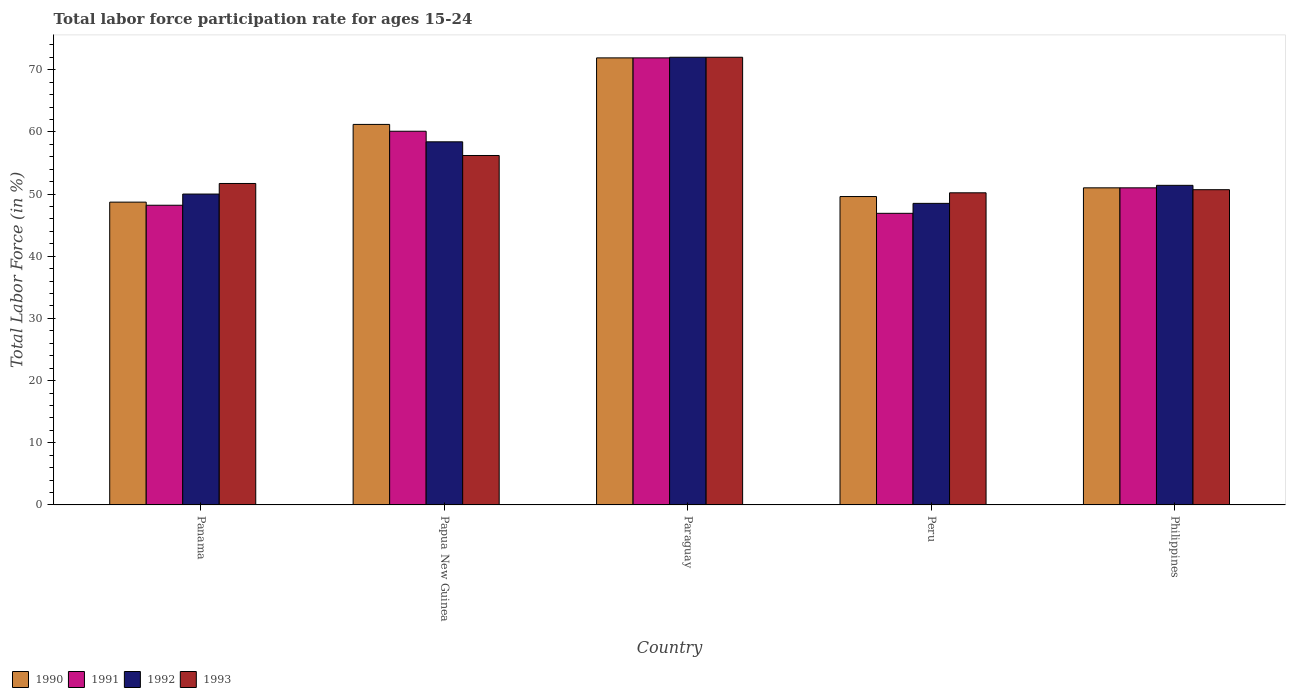How many groups of bars are there?
Your answer should be very brief. 5. Are the number of bars per tick equal to the number of legend labels?
Your answer should be compact. Yes. Are the number of bars on each tick of the X-axis equal?
Ensure brevity in your answer.  Yes. How many bars are there on the 4th tick from the left?
Keep it short and to the point. 4. How many bars are there on the 2nd tick from the right?
Your response must be concise. 4. What is the label of the 1st group of bars from the left?
Offer a very short reply. Panama. In how many cases, is the number of bars for a given country not equal to the number of legend labels?
Ensure brevity in your answer.  0. Across all countries, what is the maximum labor force participation rate in 1990?
Ensure brevity in your answer.  71.9. Across all countries, what is the minimum labor force participation rate in 1993?
Provide a succinct answer. 50.2. In which country was the labor force participation rate in 1993 maximum?
Provide a short and direct response. Paraguay. In which country was the labor force participation rate in 1990 minimum?
Your answer should be very brief. Panama. What is the total labor force participation rate in 1991 in the graph?
Provide a short and direct response. 278.1. What is the difference between the labor force participation rate in 1993 in Panama and that in Paraguay?
Make the answer very short. -20.3. What is the difference between the labor force participation rate in 1991 in Papua New Guinea and the labor force participation rate in 1993 in Paraguay?
Provide a succinct answer. -11.9. What is the average labor force participation rate in 1991 per country?
Ensure brevity in your answer.  55.62. What is the difference between the labor force participation rate of/in 1993 and labor force participation rate of/in 1992 in Panama?
Give a very brief answer. 1.7. What is the ratio of the labor force participation rate in 1990 in Panama to that in Philippines?
Provide a short and direct response. 0.95. Is the labor force participation rate in 1993 in Papua New Guinea less than that in Paraguay?
Offer a very short reply. Yes. What is the difference between the highest and the second highest labor force participation rate in 1991?
Your answer should be very brief. -9.1. What is the difference between the highest and the lowest labor force participation rate in 1991?
Provide a short and direct response. 25. Is the sum of the labor force participation rate in 1992 in Panama and Paraguay greater than the maximum labor force participation rate in 1993 across all countries?
Give a very brief answer. Yes. Is it the case that in every country, the sum of the labor force participation rate in 1990 and labor force participation rate in 1992 is greater than the sum of labor force participation rate in 1991 and labor force participation rate in 1993?
Provide a succinct answer. No. What does the 3rd bar from the left in Panama represents?
Make the answer very short. 1992. Is it the case that in every country, the sum of the labor force participation rate in 1990 and labor force participation rate in 1992 is greater than the labor force participation rate in 1993?
Your answer should be compact. Yes. How many bars are there?
Give a very brief answer. 20. Are all the bars in the graph horizontal?
Your answer should be compact. No. What is the difference between two consecutive major ticks on the Y-axis?
Make the answer very short. 10. Are the values on the major ticks of Y-axis written in scientific E-notation?
Offer a very short reply. No. Does the graph contain any zero values?
Your answer should be very brief. No. Does the graph contain grids?
Ensure brevity in your answer.  No. How are the legend labels stacked?
Provide a succinct answer. Horizontal. What is the title of the graph?
Provide a succinct answer. Total labor force participation rate for ages 15-24. What is the Total Labor Force (in %) in 1990 in Panama?
Make the answer very short. 48.7. What is the Total Labor Force (in %) in 1991 in Panama?
Your answer should be very brief. 48.2. What is the Total Labor Force (in %) in 1993 in Panama?
Your answer should be compact. 51.7. What is the Total Labor Force (in %) in 1990 in Papua New Guinea?
Your answer should be compact. 61.2. What is the Total Labor Force (in %) in 1991 in Papua New Guinea?
Your response must be concise. 60.1. What is the Total Labor Force (in %) of 1992 in Papua New Guinea?
Provide a short and direct response. 58.4. What is the Total Labor Force (in %) in 1993 in Papua New Guinea?
Offer a terse response. 56.2. What is the Total Labor Force (in %) of 1990 in Paraguay?
Keep it short and to the point. 71.9. What is the Total Labor Force (in %) of 1991 in Paraguay?
Provide a short and direct response. 71.9. What is the Total Labor Force (in %) of 1990 in Peru?
Offer a terse response. 49.6. What is the Total Labor Force (in %) in 1991 in Peru?
Provide a succinct answer. 46.9. What is the Total Labor Force (in %) of 1992 in Peru?
Ensure brevity in your answer.  48.5. What is the Total Labor Force (in %) of 1993 in Peru?
Keep it short and to the point. 50.2. What is the Total Labor Force (in %) of 1992 in Philippines?
Keep it short and to the point. 51.4. What is the Total Labor Force (in %) in 1993 in Philippines?
Your answer should be compact. 50.7. Across all countries, what is the maximum Total Labor Force (in %) in 1990?
Ensure brevity in your answer.  71.9. Across all countries, what is the maximum Total Labor Force (in %) in 1991?
Provide a short and direct response. 71.9. Across all countries, what is the maximum Total Labor Force (in %) in 1992?
Provide a short and direct response. 72. Across all countries, what is the maximum Total Labor Force (in %) of 1993?
Your answer should be very brief. 72. Across all countries, what is the minimum Total Labor Force (in %) in 1990?
Provide a succinct answer. 48.7. Across all countries, what is the minimum Total Labor Force (in %) in 1991?
Your answer should be very brief. 46.9. Across all countries, what is the minimum Total Labor Force (in %) of 1992?
Your answer should be very brief. 48.5. Across all countries, what is the minimum Total Labor Force (in %) in 1993?
Your response must be concise. 50.2. What is the total Total Labor Force (in %) of 1990 in the graph?
Ensure brevity in your answer.  282.4. What is the total Total Labor Force (in %) in 1991 in the graph?
Make the answer very short. 278.1. What is the total Total Labor Force (in %) in 1992 in the graph?
Provide a short and direct response. 280.3. What is the total Total Labor Force (in %) of 1993 in the graph?
Ensure brevity in your answer.  280.8. What is the difference between the Total Labor Force (in %) in 1990 in Panama and that in Papua New Guinea?
Your answer should be very brief. -12.5. What is the difference between the Total Labor Force (in %) in 1991 in Panama and that in Papua New Guinea?
Provide a succinct answer. -11.9. What is the difference between the Total Labor Force (in %) in 1990 in Panama and that in Paraguay?
Your answer should be very brief. -23.2. What is the difference between the Total Labor Force (in %) of 1991 in Panama and that in Paraguay?
Offer a very short reply. -23.7. What is the difference between the Total Labor Force (in %) in 1992 in Panama and that in Paraguay?
Your answer should be very brief. -22. What is the difference between the Total Labor Force (in %) of 1993 in Panama and that in Paraguay?
Your answer should be compact. -20.3. What is the difference between the Total Labor Force (in %) of 1990 in Panama and that in Peru?
Offer a very short reply. -0.9. What is the difference between the Total Labor Force (in %) of 1992 in Panama and that in Peru?
Keep it short and to the point. 1.5. What is the difference between the Total Labor Force (in %) in 1990 in Panama and that in Philippines?
Your answer should be very brief. -2.3. What is the difference between the Total Labor Force (in %) in 1992 in Panama and that in Philippines?
Give a very brief answer. -1.4. What is the difference between the Total Labor Force (in %) in 1992 in Papua New Guinea and that in Paraguay?
Your answer should be compact. -13.6. What is the difference between the Total Labor Force (in %) in 1993 in Papua New Guinea and that in Paraguay?
Ensure brevity in your answer.  -15.8. What is the difference between the Total Labor Force (in %) of 1990 in Papua New Guinea and that in Peru?
Your answer should be very brief. 11.6. What is the difference between the Total Labor Force (in %) in 1991 in Papua New Guinea and that in Peru?
Your answer should be compact. 13.2. What is the difference between the Total Labor Force (in %) of 1993 in Papua New Guinea and that in Peru?
Provide a short and direct response. 6. What is the difference between the Total Labor Force (in %) in 1991 in Papua New Guinea and that in Philippines?
Give a very brief answer. 9.1. What is the difference between the Total Labor Force (in %) of 1993 in Papua New Guinea and that in Philippines?
Keep it short and to the point. 5.5. What is the difference between the Total Labor Force (in %) of 1990 in Paraguay and that in Peru?
Offer a terse response. 22.3. What is the difference between the Total Labor Force (in %) in 1992 in Paraguay and that in Peru?
Your response must be concise. 23.5. What is the difference between the Total Labor Force (in %) of 1993 in Paraguay and that in Peru?
Your answer should be compact. 21.8. What is the difference between the Total Labor Force (in %) of 1990 in Paraguay and that in Philippines?
Your response must be concise. 20.9. What is the difference between the Total Labor Force (in %) in 1991 in Paraguay and that in Philippines?
Give a very brief answer. 20.9. What is the difference between the Total Labor Force (in %) in 1992 in Paraguay and that in Philippines?
Ensure brevity in your answer.  20.6. What is the difference between the Total Labor Force (in %) in 1993 in Paraguay and that in Philippines?
Your answer should be compact. 21.3. What is the difference between the Total Labor Force (in %) of 1992 in Peru and that in Philippines?
Your response must be concise. -2.9. What is the difference between the Total Labor Force (in %) in 1993 in Peru and that in Philippines?
Keep it short and to the point. -0.5. What is the difference between the Total Labor Force (in %) in 1990 in Panama and the Total Labor Force (in %) in 1991 in Papua New Guinea?
Make the answer very short. -11.4. What is the difference between the Total Labor Force (in %) of 1991 in Panama and the Total Labor Force (in %) of 1992 in Papua New Guinea?
Your answer should be very brief. -10.2. What is the difference between the Total Labor Force (in %) of 1991 in Panama and the Total Labor Force (in %) of 1993 in Papua New Guinea?
Ensure brevity in your answer.  -8. What is the difference between the Total Labor Force (in %) in 1992 in Panama and the Total Labor Force (in %) in 1993 in Papua New Guinea?
Offer a very short reply. -6.2. What is the difference between the Total Labor Force (in %) in 1990 in Panama and the Total Labor Force (in %) in 1991 in Paraguay?
Keep it short and to the point. -23.2. What is the difference between the Total Labor Force (in %) of 1990 in Panama and the Total Labor Force (in %) of 1992 in Paraguay?
Make the answer very short. -23.3. What is the difference between the Total Labor Force (in %) of 1990 in Panama and the Total Labor Force (in %) of 1993 in Paraguay?
Ensure brevity in your answer.  -23.3. What is the difference between the Total Labor Force (in %) of 1991 in Panama and the Total Labor Force (in %) of 1992 in Paraguay?
Ensure brevity in your answer.  -23.8. What is the difference between the Total Labor Force (in %) in 1991 in Panama and the Total Labor Force (in %) in 1993 in Paraguay?
Your response must be concise. -23.8. What is the difference between the Total Labor Force (in %) of 1990 in Panama and the Total Labor Force (in %) of 1991 in Peru?
Your answer should be compact. 1.8. What is the difference between the Total Labor Force (in %) in 1990 in Panama and the Total Labor Force (in %) in 1992 in Peru?
Make the answer very short. 0.2. What is the difference between the Total Labor Force (in %) of 1990 in Panama and the Total Labor Force (in %) of 1993 in Peru?
Your response must be concise. -1.5. What is the difference between the Total Labor Force (in %) in 1991 in Panama and the Total Labor Force (in %) in 1992 in Peru?
Offer a very short reply. -0.3. What is the difference between the Total Labor Force (in %) in 1992 in Panama and the Total Labor Force (in %) in 1993 in Peru?
Provide a short and direct response. -0.2. What is the difference between the Total Labor Force (in %) of 1991 in Panama and the Total Labor Force (in %) of 1992 in Philippines?
Provide a succinct answer. -3.2. What is the difference between the Total Labor Force (in %) in 1992 in Panama and the Total Labor Force (in %) in 1993 in Philippines?
Make the answer very short. -0.7. What is the difference between the Total Labor Force (in %) of 1990 in Papua New Guinea and the Total Labor Force (in %) of 1991 in Paraguay?
Make the answer very short. -10.7. What is the difference between the Total Labor Force (in %) of 1990 in Papua New Guinea and the Total Labor Force (in %) of 1992 in Paraguay?
Your response must be concise. -10.8. What is the difference between the Total Labor Force (in %) in 1991 in Papua New Guinea and the Total Labor Force (in %) in 1992 in Paraguay?
Keep it short and to the point. -11.9. What is the difference between the Total Labor Force (in %) in 1992 in Papua New Guinea and the Total Labor Force (in %) in 1993 in Paraguay?
Make the answer very short. -13.6. What is the difference between the Total Labor Force (in %) of 1990 in Papua New Guinea and the Total Labor Force (in %) of 1992 in Peru?
Provide a short and direct response. 12.7. What is the difference between the Total Labor Force (in %) in 1990 in Papua New Guinea and the Total Labor Force (in %) in 1993 in Peru?
Keep it short and to the point. 11. What is the difference between the Total Labor Force (in %) of 1991 in Papua New Guinea and the Total Labor Force (in %) of 1992 in Peru?
Your answer should be very brief. 11.6. What is the difference between the Total Labor Force (in %) in 1990 in Papua New Guinea and the Total Labor Force (in %) in 1991 in Philippines?
Your answer should be very brief. 10.2. What is the difference between the Total Labor Force (in %) in 1992 in Papua New Guinea and the Total Labor Force (in %) in 1993 in Philippines?
Make the answer very short. 7.7. What is the difference between the Total Labor Force (in %) in 1990 in Paraguay and the Total Labor Force (in %) in 1991 in Peru?
Make the answer very short. 25. What is the difference between the Total Labor Force (in %) in 1990 in Paraguay and the Total Labor Force (in %) in 1992 in Peru?
Keep it short and to the point. 23.4. What is the difference between the Total Labor Force (in %) of 1990 in Paraguay and the Total Labor Force (in %) of 1993 in Peru?
Provide a short and direct response. 21.7. What is the difference between the Total Labor Force (in %) in 1991 in Paraguay and the Total Labor Force (in %) in 1992 in Peru?
Give a very brief answer. 23.4. What is the difference between the Total Labor Force (in %) of 1991 in Paraguay and the Total Labor Force (in %) of 1993 in Peru?
Provide a succinct answer. 21.7. What is the difference between the Total Labor Force (in %) of 1992 in Paraguay and the Total Labor Force (in %) of 1993 in Peru?
Offer a very short reply. 21.8. What is the difference between the Total Labor Force (in %) in 1990 in Paraguay and the Total Labor Force (in %) in 1991 in Philippines?
Offer a very short reply. 20.9. What is the difference between the Total Labor Force (in %) in 1990 in Paraguay and the Total Labor Force (in %) in 1993 in Philippines?
Make the answer very short. 21.2. What is the difference between the Total Labor Force (in %) in 1991 in Paraguay and the Total Labor Force (in %) in 1992 in Philippines?
Ensure brevity in your answer.  20.5. What is the difference between the Total Labor Force (in %) of 1991 in Paraguay and the Total Labor Force (in %) of 1993 in Philippines?
Offer a terse response. 21.2. What is the difference between the Total Labor Force (in %) in 1992 in Paraguay and the Total Labor Force (in %) in 1993 in Philippines?
Ensure brevity in your answer.  21.3. What is the difference between the Total Labor Force (in %) in 1990 in Peru and the Total Labor Force (in %) in 1991 in Philippines?
Offer a very short reply. -1.4. What is the difference between the Total Labor Force (in %) in 1991 in Peru and the Total Labor Force (in %) in 1992 in Philippines?
Keep it short and to the point. -4.5. What is the difference between the Total Labor Force (in %) in 1992 in Peru and the Total Labor Force (in %) in 1993 in Philippines?
Your answer should be very brief. -2.2. What is the average Total Labor Force (in %) in 1990 per country?
Make the answer very short. 56.48. What is the average Total Labor Force (in %) of 1991 per country?
Keep it short and to the point. 55.62. What is the average Total Labor Force (in %) in 1992 per country?
Provide a short and direct response. 56.06. What is the average Total Labor Force (in %) of 1993 per country?
Your answer should be very brief. 56.16. What is the difference between the Total Labor Force (in %) of 1990 and Total Labor Force (in %) of 1991 in Panama?
Offer a terse response. 0.5. What is the difference between the Total Labor Force (in %) of 1990 and Total Labor Force (in %) of 1992 in Panama?
Your answer should be very brief. -1.3. What is the difference between the Total Labor Force (in %) in 1990 and Total Labor Force (in %) in 1993 in Panama?
Offer a very short reply. -3. What is the difference between the Total Labor Force (in %) in 1992 and Total Labor Force (in %) in 1993 in Panama?
Ensure brevity in your answer.  -1.7. What is the difference between the Total Labor Force (in %) of 1990 and Total Labor Force (in %) of 1991 in Papua New Guinea?
Make the answer very short. 1.1. What is the difference between the Total Labor Force (in %) in 1990 and Total Labor Force (in %) in 1992 in Papua New Guinea?
Offer a very short reply. 2.8. What is the difference between the Total Labor Force (in %) in 1991 and Total Labor Force (in %) in 1992 in Papua New Guinea?
Provide a short and direct response. 1.7. What is the difference between the Total Labor Force (in %) of 1991 and Total Labor Force (in %) of 1993 in Papua New Guinea?
Offer a very short reply. 3.9. What is the difference between the Total Labor Force (in %) of 1990 and Total Labor Force (in %) of 1993 in Paraguay?
Offer a terse response. -0.1. What is the difference between the Total Labor Force (in %) in 1991 and Total Labor Force (in %) in 1992 in Paraguay?
Your answer should be very brief. -0.1. What is the difference between the Total Labor Force (in %) in 1991 and Total Labor Force (in %) in 1993 in Paraguay?
Your answer should be compact. -0.1. What is the difference between the Total Labor Force (in %) of 1990 and Total Labor Force (in %) of 1992 in Peru?
Offer a terse response. 1.1. What is the difference between the Total Labor Force (in %) of 1991 and Total Labor Force (in %) of 1993 in Peru?
Provide a short and direct response. -3.3. What is the difference between the Total Labor Force (in %) of 1992 and Total Labor Force (in %) of 1993 in Peru?
Keep it short and to the point. -1.7. What is the difference between the Total Labor Force (in %) of 1990 and Total Labor Force (in %) of 1991 in Philippines?
Offer a very short reply. 0. What is the difference between the Total Labor Force (in %) in 1990 and Total Labor Force (in %) in 1992 in Philippines?
Offer a terse response. -0.4. What is the difference between the Total Labor Force (in %) in 1990 and Total Labor Force (in %) in 1993 in Philippines?
Your answer should be very brief. 0.3. What is the difference between the Total Labor Force (in %) in 1992 and Total Labor Force (in %) in 1993 in Philippines?
Your answer should be very brief. 0.7. What is the ratio of the Total Labor Force (in %) in 1990 in Panama to that in Papua New Guinea?
Offer a very short reply. 0.8. What is the ratio of the Total Labor Force (in %) of 1991 in Panama to that in Papua New Guinea?
Keep it short and to the point. 0.8. What is the ratio of the Total Labor Force (in %) in 1992 in Panama to that in Papua New Guinea?
Make the answer very short. 0.86. What is the ratio of the Total Labor Force (in %) of 1993 in Panama to that in Papua New Guinea?
Your answer should be compact. 0.92. What is the ratio of the Total Labor Force (in %) in 1990 in Panama to that in Paraguay?
Provide a succinct answer. 0.68. What is the ratio of the Total Labor Force (in %) of 1991 in Panama to that in Paraguay?
Make the answer very short. 0.67. What is the ratio of the Total Labor Force (in %) in 1992 in Panama to that in Paraguay?
Provide a succinct answer. 0.69. What is the ratio of the Total Labor Force (in %) of 1993 in Panama to that in Paraguay?
Your response must be concise. 0.72. What is the ratio of the Total Labor Force (in %) of 1990 in Panama to that in Peru?
Offer a very short reply. 0.98. What is the ratio of the Total Labor Force (in %) of 1991 in Panama to that in Peru?
Make the answer very short. 1.03. What is the ratio of the Total Labor Force (in %) of 1992 in Panama to that in Peru?
Your answer should be very brief. 1.03. What is the ratio of the Total Labor Force (in %) of 1993 in Panama to that in Peru?
Make the answer very short. 1.03. What is the ratio of the Total Labor Force (in %) of 1990 in Panama to that in Philippines?
Offer a terse response. 0.95. What is the ratio of the Total Labor Force (in %) in 1991 in Panama to that in Philippines?
Offer a terse response. 0.95. What is the ratio of the Total Labor Force (in %) of 1992 in Panama to that in Philippines?
Give a very brief answer. 0.97. What is the ratio of the Total Labor Force (in %) in 1993 in Panama to that in Philippines?
Provide a short and direct response. 1.02. What is the ratio of the Total Labor Force (in %) in 1990 in Papua New Guinea to that in Paraguay?
Your answer should be compact. 0.85. What is the ratio of the Total Labor Force (in %) of 1991 in Papua New Guinea to that in Paraguay?
Your answer should be compact. 0.84. What is the ratio of the Total Labor Force (in %) in 1992 in Papua New Guinea to that in Paraguay?
Your response must be concise. 0.81. What is the ratio of the Total Labor Force (in %) of 1993 in Papua New Guinea to that in Paraguay?
Provide a short and direct response. 0.78. What is the ratio of the Total Labor Force (in %) in 1990 in Papua New Guinea to that in Peru?
Give a very brief answer. 1.23. What is the ratio of the Total Labor Force (in %) in 1991 in Papua New Guinea to that in Peru?
Your answer should be compact. 1.28. What is the ratio of the Total Labor Force (in %) in 1992 in Papua New Guinea to that in Peru?
Give a very brief answer. 1.2. What is the ratio of the Total Labor Force (in %) of 1993 in Papua New Guinea to that in Peru?
Provide a succinct answer. 1.12. What is the ratio of the Total Labor Force (in %) of 1991 in Papua New Guinea to that in Philippines?
Offer a very short reply. 1.18. What is the ratio of the Total Labor Force (in %) of 1992 in Papua New Guinea to that in Philippines?
Keep it short and to the point. 1.14. What is the ratio of the Total Labor Force (in %) in 1993 in Papua New Guinea to that in Philippines?
Ensure brevity in your answer.  1.11. What is the ratio of the Total Labor Force (in %) of 1990 in Paraguay to that in Peru?
Keep it short and to the point. 1.45. What is the ratio of the Total Labor Force (in %) of 1991 in Paraguay to that in Peru?
Offer a very short reply. 1.53. What is the ratio of the Total Labor Force (in %) of 1992 in Paraguay to that in Peru?
Your response must be concise. 1.48. What is the ratio of the Total Labor Force (in %) in 1993 in Paraguay to that in Peru?
Your answer should be compact. 1.43. What is the ratio of the Total Labor Force (in %) of 1990 in Paraguay to that in Philippines?
Your answer should be compact. 1.41. What is the ratio of the Total Labor Force (in %) in 1991 in Paraguay to that in Philippines?
Make the answer very short. 1.41. What is the ratio of the Total Labor Force (in %) of 1992 in Paraguay to that in Philippines?
Provide a succinct answer. 1.4. What is the ratio of the Total Labor Force (in %) of 1993 in Paraguay to that in Philippines?
Give a very brief answer. 1.42. What is the ratio of the Total Labor Force (in %) of 1990 in Peru to that in Philippines?
Make the answer very short. 0.97. What is the ratio of the Total Labor Force (in %) in 1991 in Peru to that in Philippines?
Make the answer very short. 0.92. What is the ratio of the Total Labor Force (in %) of 1992 in Peru to that in Philippines?
Your response must be concise. 0.94. What is the ratio of the Total Labor Force (in %) in 1993 in Peru to that in Philippines?
Offer a very short reply. 0.99. What is the difference between the highest and the second highest Total Labor Force (in %) in 1992?
Offer a very short reply. 13.6. What is the difference between the highest and the second highest Total Labor Force (in %) of 1993?
Make the answer very short. 15.8. What is the difference between the highest and the lowest Total Labor Force (in %) of 1990?
Provide a short and direct response. 23.2. What is the difference between the highest and the lowest Total Labor Force (in %) of 1993?
Provide a succinct answer. 21.8. 